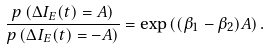<formula> <loc_0><loc_0><loc_500><loc_500>\frac { p \left ( \Delta I _ { E } ( t ) = A \right ) } { p \left ( \Delta I _ { E } ( t ) = - A \right ) } = \exp \left ( ( \beta _ { 1 } - \beta _ { 2 } ) A \right ) .</formula> 